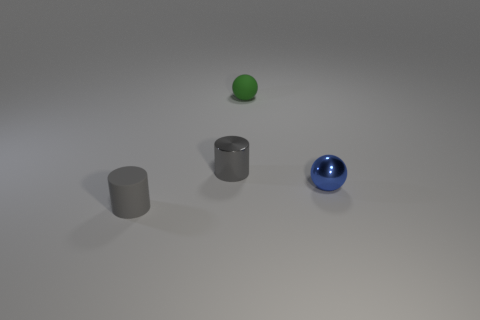Add 1 red balls. How many red balls exist? 1 Add 4 gray objects. How many objects exist? 8 Subtract 0 brown cylinders. How many objects are left? 4 Subtract 2 spheres. How many spheres are left? 0 Subtract all green spheres. Subtract all yellow blocks. How many spheres are left? 1 Subtract all red cubes. How many blue spheres are left? 1 Subtract all brown matte things. Subtract all tiny blue spheres. How many objects are left? 3 Add 2 tiny metal cylinders. How many tiny metal cylinders are left? 3 